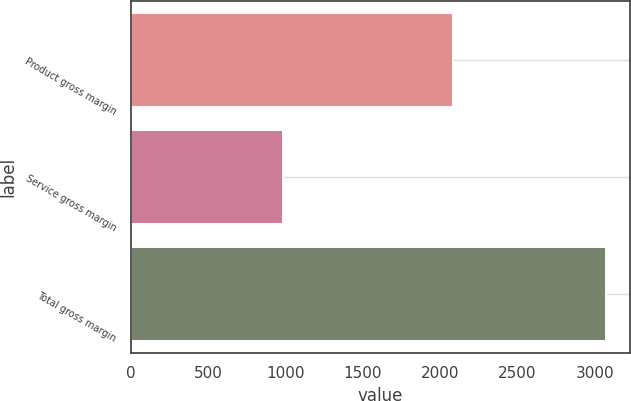<chart> <loc_0><loc_0><loc_500><loc_500><bar_chart><fcel>Product gross margin<fcel>Service gross margin<fcel>Total gross margin<nl><fcel>2085.3<fcel>986.8<fcel>3072.1<nl></chart> 